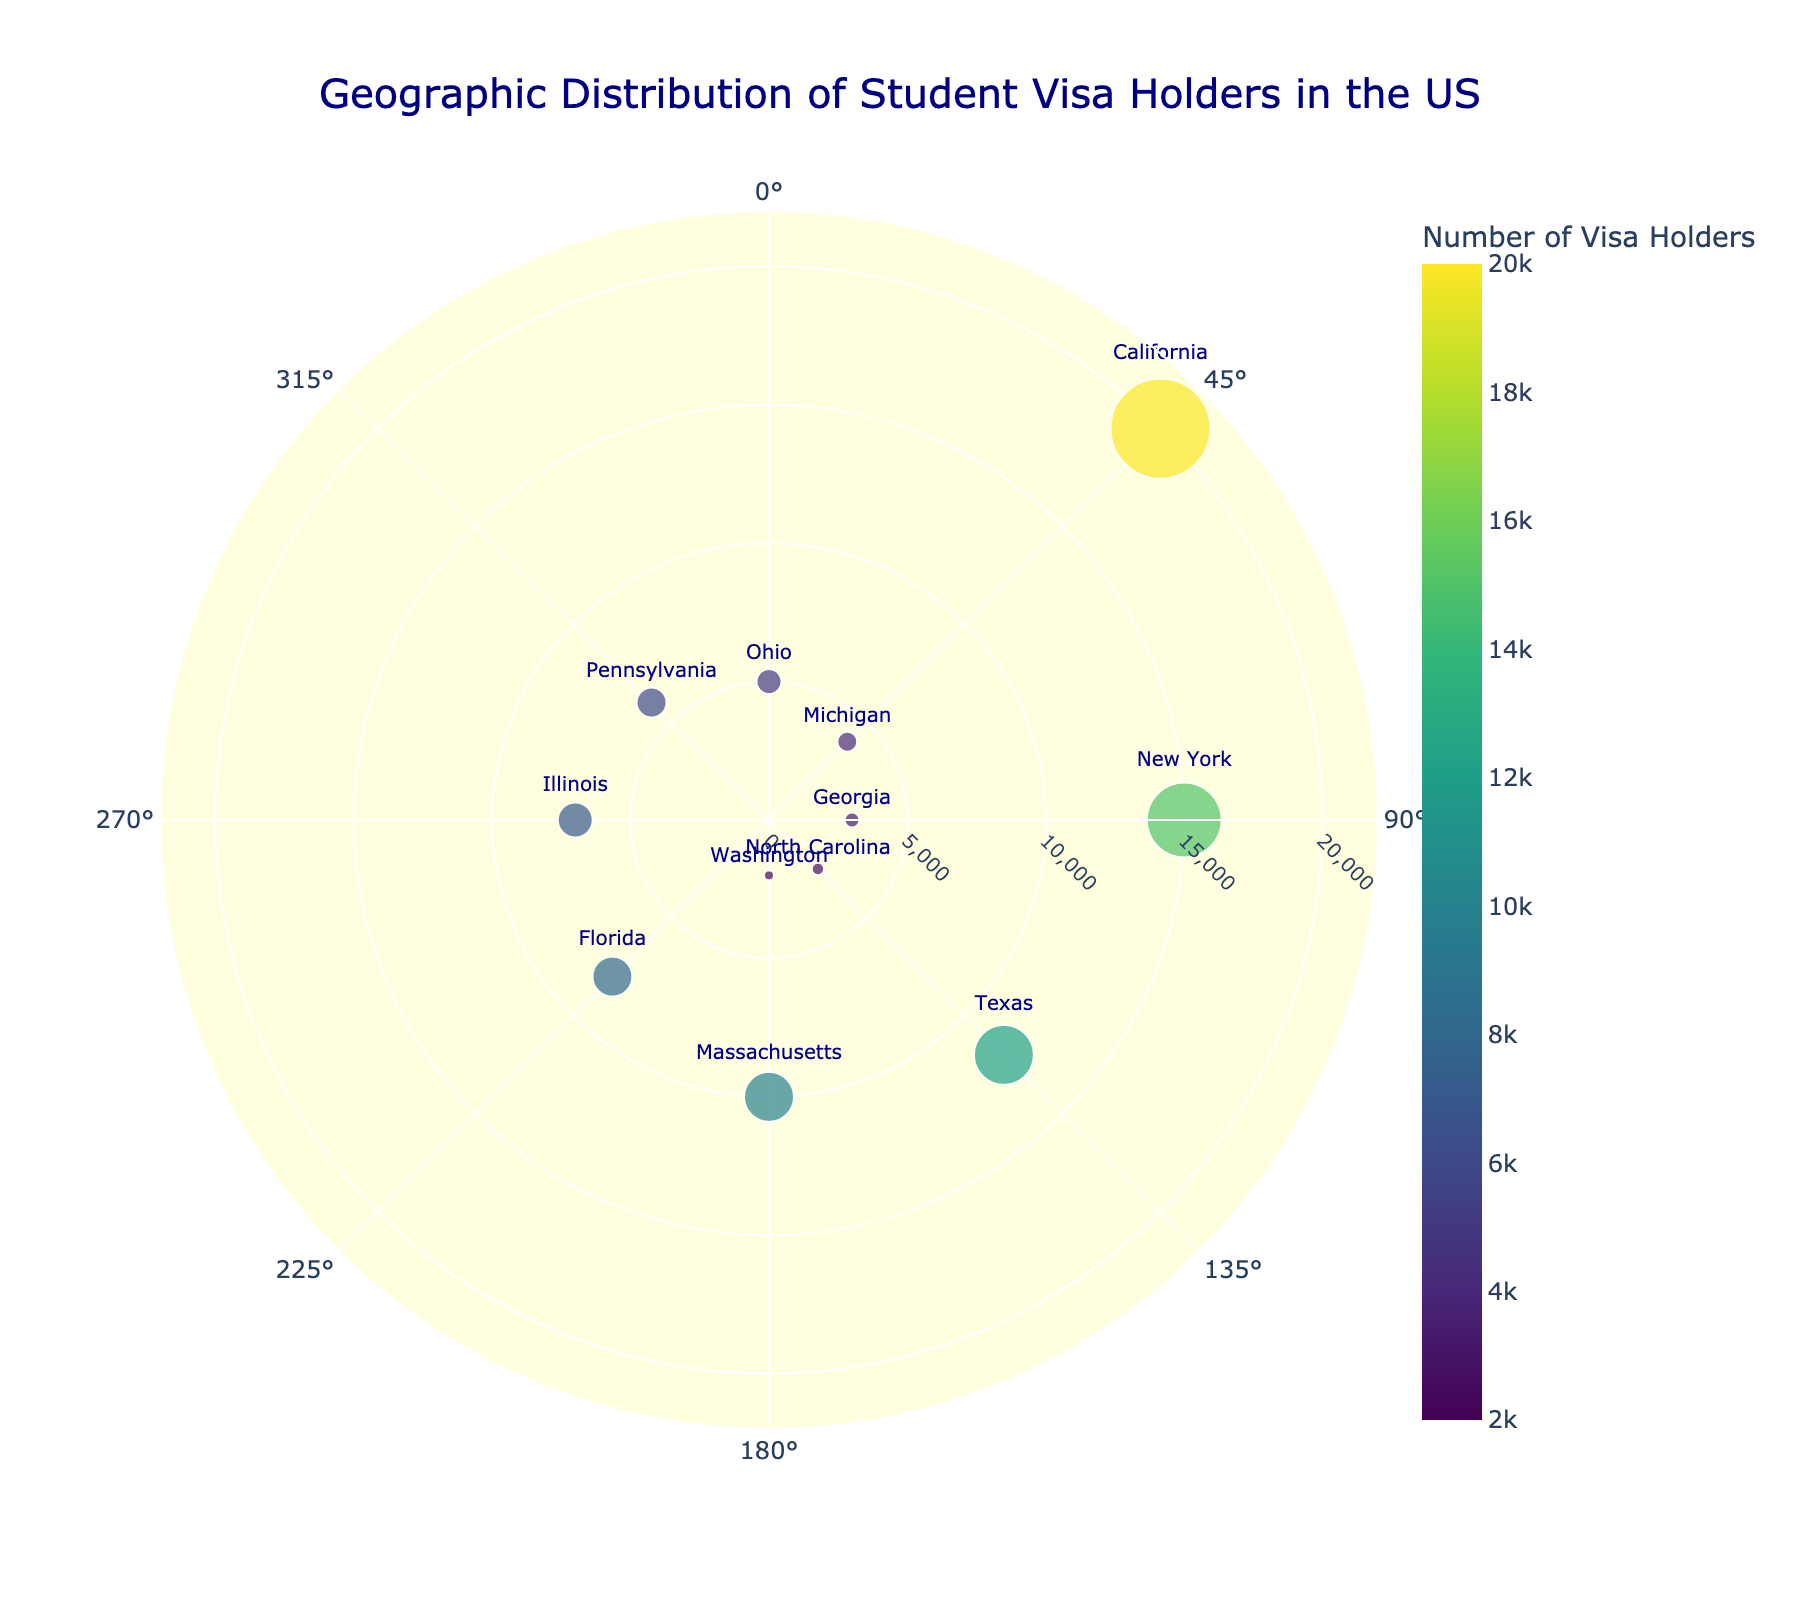What is the title of the chart? The title is displayed at the top of the chart, typically in a larger and distinct font color. The specific title for this chart can be found by observing this area.
Answer: Geographic Distribution of Student Visa Holders in the US How many states are represented in the chart? The number of unique points or markers on the chart corresponds to the number of states represented. Counting these points provides the answer.
Answer: 12 Which state has the highest number of student visa holders? The state with the largest radius marker on the chart represents the highest number of student visa holders. The data label or hover text can also identify this.
Answer: California What is the color scale used for the radius of the markers? The color of the markers correlates with the number of visa holders and follows a specific color gradient. Observing the legend or color bar shows the colors ranging from the smallest to the largest value.
Answer: Viridis What is the average number of student visa holders across all states? Sum all the radius values for each state and divide by the number of states to find the average. Calculation: (20000 + 15000 + 12000 + 10000 + 8000 + 7000 + 6000 + 5000 + 4000 + 3000 + 2500 + 2000) / 12 = 8166.67
Answer: 8166.67 Which states have fewer student visa holders than Illinois? Identify the radius value for Illinois and compare it with other states' radius values. States with lower values than Illinois's 7000 are listed.
Answer: Pennsylvania, Ohio, Michigan, Georgia, North Carolina, Washington What is the sum of student visa holders for California and New York combined? Add the radius values of California and New York together. Calculation: 20000 + 15000 = 35000
Answer: 35000 How does the number of student visa holders in Massachusetts compare to Texas? Compare the radius values of Massachusetts and Texas, checking which is larger or smaller. Massachusetts has a radius of 10000, while Texas has 12000.
Answer: Less than Texas What is the range of the radial axis in the chart? The range of the radial axis indicates the extent of the radius values displayed. It can be determined by observing the axis labels or ticks.
Answer: 0 to 22000 Which state is located at the 225-degree angle, and what is its number of student visa holders? Locate the state positioned at the 225-degree angle and check its corresponding radius value.
Answer: Florida, 8000 